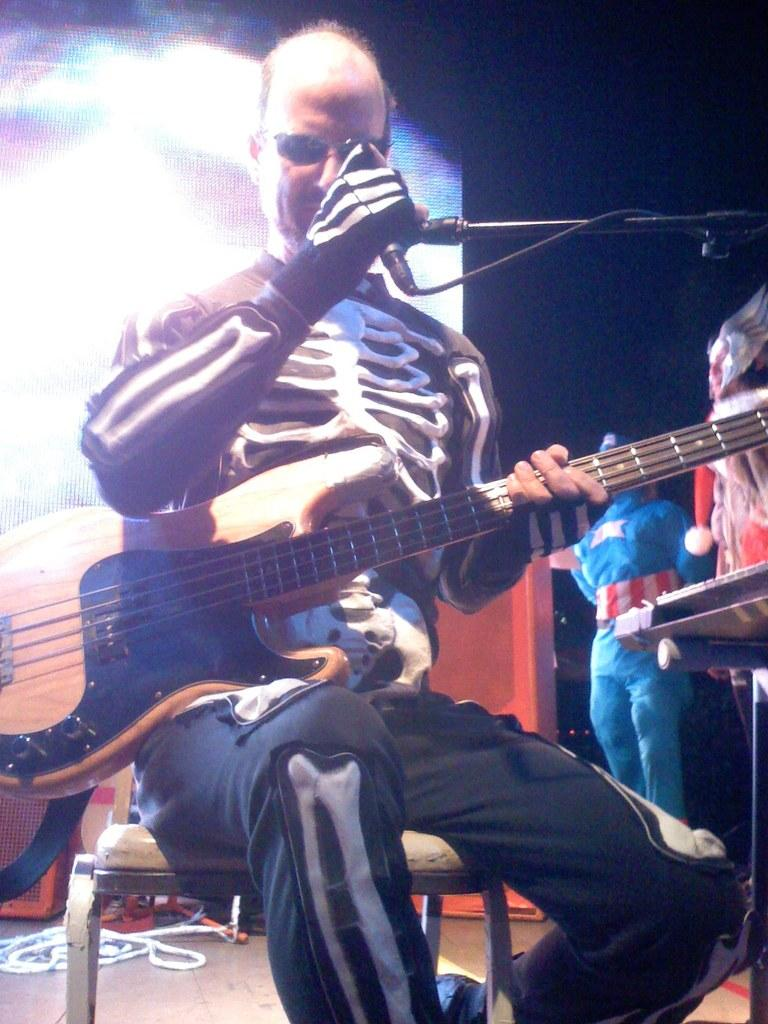What is the main subject of the image? The main subject of the image is a man. What is the man doing in the image? The man is sitting on a chair, playing a guitar, and holding a microphone. What can be seen in the background of the image? There is a screen in the background of the image. What is visible beneath the man in the image? There is a floor visible in the image. What type of disgust can be seen on the man's face in the image? There is no indication of disgust on the man's face in the image. Can you tell me how many doors are visible in the image? There are no doors visible in the image. 